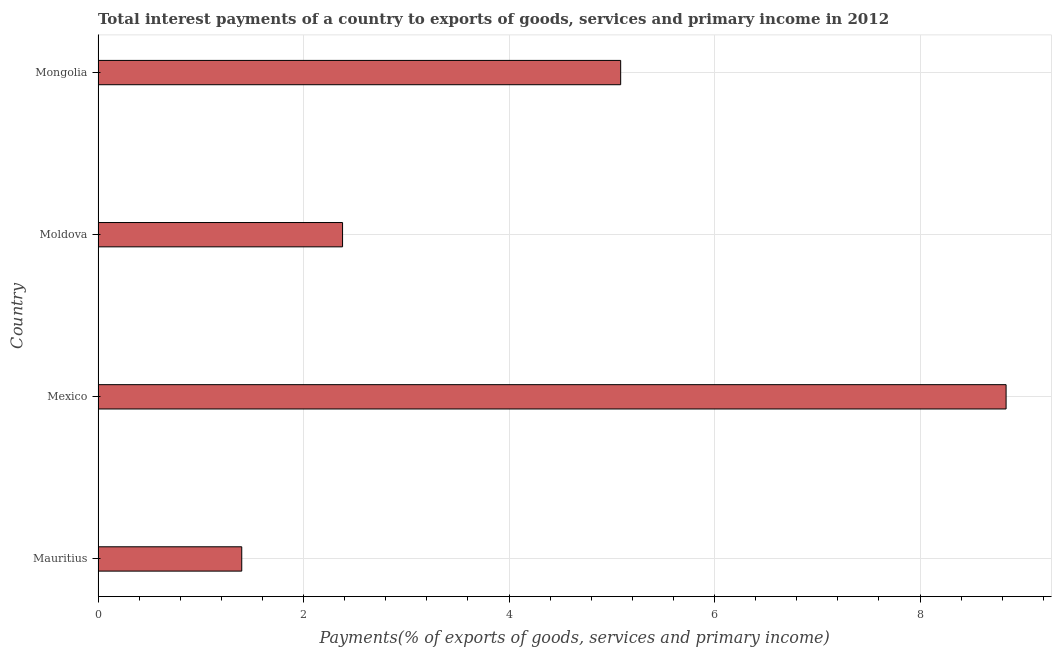What is the title of the graph?
Keep it short and to the point. Total interest payments of a country to exports of goods, services and primary income in 2012. What is the label or title of the X-axis?
Make the answer very short. Payments(% of exports of goods, services and primary income). What is the label or title of the Y-axis?
Your answer should be very brief. Country. What is the total interest payments on external debt in Mexico?
Offer a very short reply. 8.84. Across all countries, what is the maximum total interest payments on external debt?
Provide a succinct answer. 8.84. Across all countries, what is the minimum total interest payments on external debt?
Provide a short and direct response. 1.4. In which country was the total interest payments on external debt maximum?
Offer a very short reply. Mexico. In which country was the total interest payments on external debt minimum?
Ensure brevity in your answer.  Mauritius. What is the sum of the total interest payments on external debt?
Ensure brevity in your answer.  17.7. What is the difference between the total interest payments on external debt in Moldova and Mongolia?
Your answer should be compact. -2.71. What is the average total interest payments on external debt per country?
Provide a succinct answer. 4.43. What is the median total interest payments on external debt?
Make the answer very short. 3.73. What is the ratio of the total interest payments on external debt in Mexico to that in Moldova?
Your response must be concise. 3.71. Is the total interest payments on external debt in Mauritius less than that in Mongolia?
Your response must be concise. Yes. Is the difference between the total interest payments on external debt in Mauritius and Moldova greater than the difference between any two countries?
Make the answer very short. No. What is the difference between the highest and the second highest total interest payments on external debt?
Your answer should be very brief. 3.75. What is the difference between the highest and the lowest total interest payments on external debt?
Offer a terse response. 7.44. How many bars are there?
Keep it short and to the point. 4. Are all the bars in the graph horizontal?
Provide a short and direct response. Yes. How many countries are there in the graph?
Your answer should be very brief. 4. Are the values on the major ticks of X-axis written in scientific E-notation?
Keep it short and to the point. No. What is the Payments(% of exports of goods, services and primary income) in Mauritius?
Provide a short and direct response. 1.4. What is the Payments(% of exports of goods, services and primary income) in Mexico?
Make the answer very short. 8.84. What is the Payments(% of exports of goods, services and primary income) of Moldova?
Provide a succinct answer. 2.38. What is the Payments(% of exports of goods, services and primary income) in Mongolia?
Provide a succinct answer. 5.09. What is the difference between the Payments(% of exports of goods, services and primary income) in Mauritius and Mexico?
Ensure brevity in your answer.  -7.44. What is the difference between the Payments(% of exports of goods, services and primary income) in Mauritius and Moldova?
Your response must be concise. -0.98. What is the difference between the Payments(% of exports of goods, services and primary income) in Mauritius and Mongolia?
Provide a succinct answer. -3.69. What is the difference between the Payments(% of exports of goods, services and primary income) in Mexico and Moldova?
Your response must be concise. 6.46. What is the difference between the Payments(% of exports of goods, services and primary income) in Mexico and Mongolia?
Give a very brief answer. 3.75. What is the difference between the Payments(% of exports of goods, services and primary income) in Moldova and Mongolia?
Offer a very short reply. -2.71. What is the ratio of the Payments(% of exports of goods, services and primary income) in Mauritius to that in Mexico?
Provide a short and direct response. 0.16. What is the ratio of the Payments(% of exports of goods, services and primary income) in Mauritius to that in Moldova?
Keep it short and to the point. 0.59. What is the ratio of the Payments(% of exports of goods, services and primary income) in Mauritius to that in Mongolia?
Your response must be concise. 0.28. What is the ratio of the Payments(% of exports of goods, services and primary income) in Mexico to that in Moldova?
Offer a terse response. 3.71. What is the ratio of the Payments(% of exports of goods, services and primary income) in Mexico to that in Mongolia?
Give a very brief answer. 1.74. What is the ratio of the Payments(% of exports of goods, services and primary income) in Moldova to that in Mongolia?
Provide a short and direct response. 0.47. 